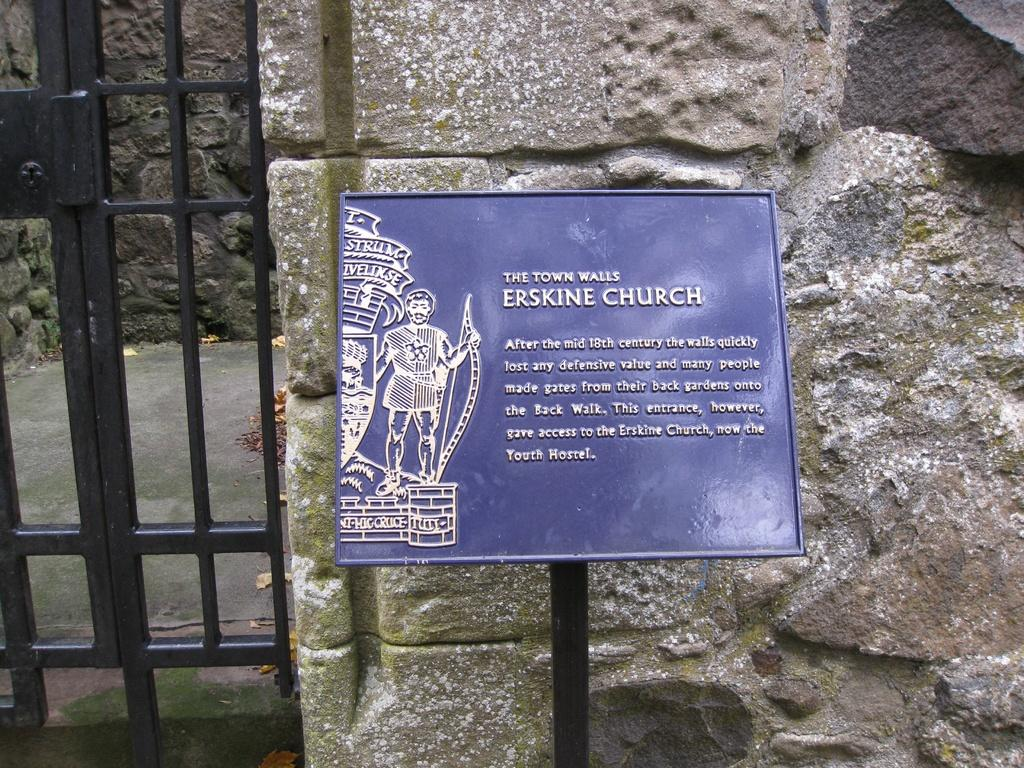What is the main object in the center of the image? There is a board in the center of the image. What can be seen in the grass in the background of the image? There is a gate and a wall in the background of the image. How many legs can be seen on the guide in the image? There is no guide present in the image, and therefore no legs can be seen. 